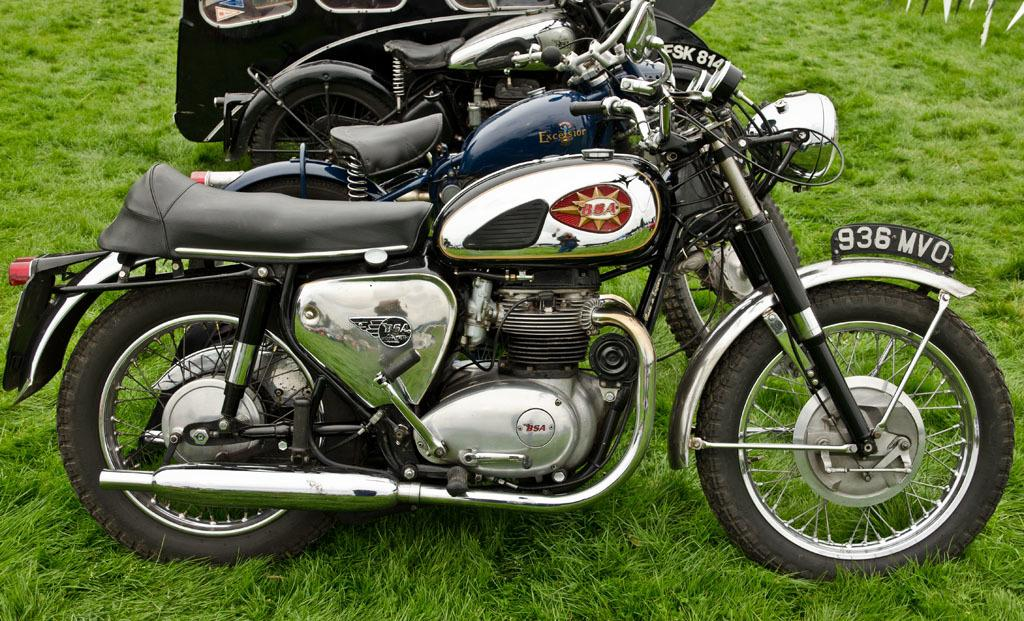How many bikes are visible in the image? There are three bikes in the image. What is the surface on which the bikes are placed? The bikes are on a grassy surface. What type of band is playing music in the background of the image? There is no band present in the image, and therefore no music can be heard. 